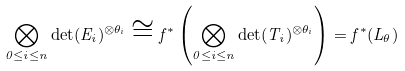<formula> <loc_0><loc_0><loc_500><loc_500>\bigotimes _ { 0 \leq i \leq n } \det ( E _ { i } ) ^ { \otimes \theta _ { i } } \cong f ^ { * } \left ( \bigotimes _ { 0 \leq i \leq n } \det ( T _ { i } ) ^ { \otimes \theta _ { i } } \right ) = f ^ { * } ( L _ { \theta } )</formula> 